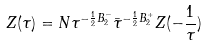<formula> <loc_0><loc_0><loc_500><loc_500>Z ( \tau ) = N \tau ^ { - \frac { 1 } { 2 } B _ { 2 } ^ { - } } \bar { \tau } ^ { - \frac { 1 } { 2 } B _ { 2 } ^ { + } } Z ( - \frac { 1 } { \tau } )</formula> 